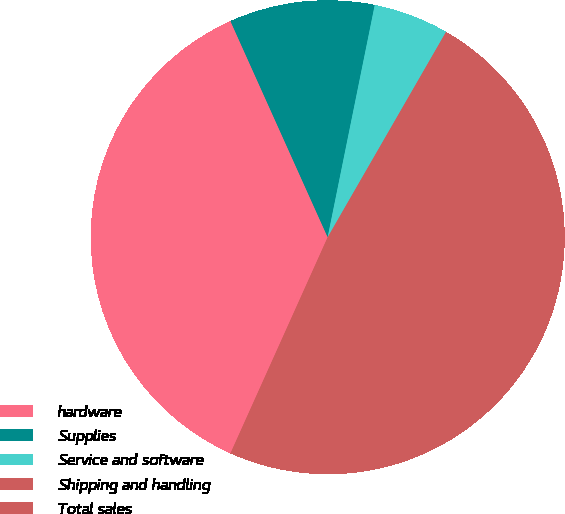Convert chart. <chart><loc_0><loc_0><loc_500><loc_500><pie_chart><fcel>hardware<fcel>Supplies<fcel>Service and software<fcel>Shipping and handling<fcel>Total sales<nl><fcel>36.54%<fcel>9.91%<fcel>5.14%<fcel>0.38%<fcel>48.02%<nl></chart> 